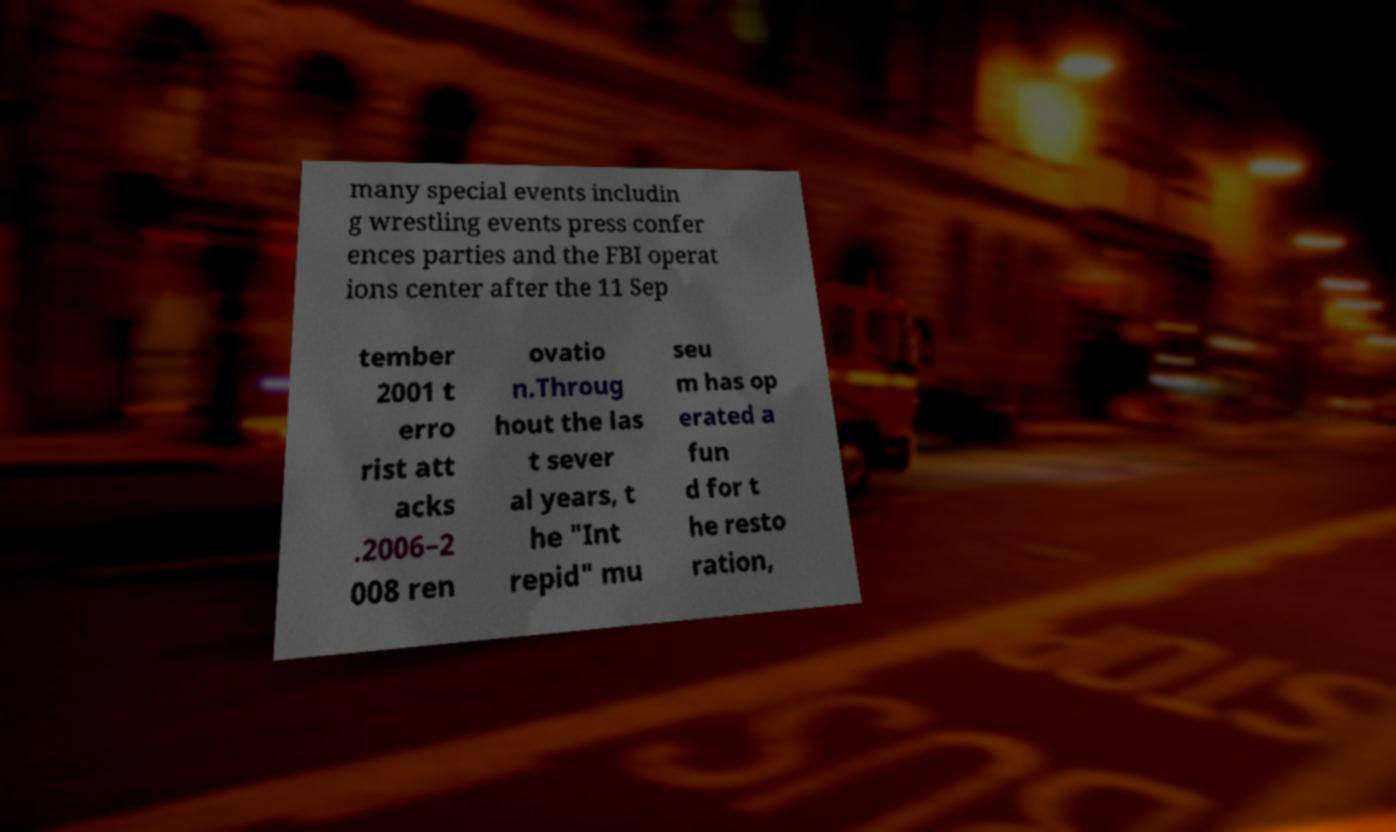Please identify and transcribe the text found in this image. many special events includin g wrestling events press confer ences parties and the FBI operat ions center after the 11 Sep tember 2001 t erro rist att acks .2006–2 008 ren ovatio n.Throug hout the las t sever al years, t he "Int repid" mu seu m has op erated a fun d for t he resto ration, 